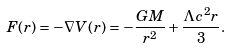Convert formula to latex. <formula><loc_0><loc_0><loc_500><loc_500>F ( r ) = - \nabla V ( r ) = - \frac { G M } { r ^ { 2 } } + \frac { \Lambda c ^ { 2 } r } { 3 } .</formula> 